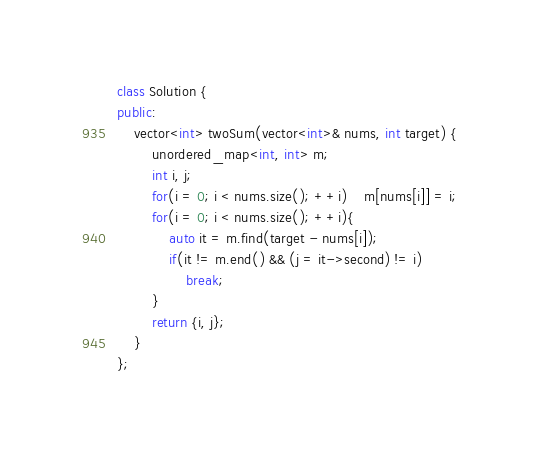<code> <loc_0><loc_0><loc_500><loc_500><_C++_>class Solution {
public:
    vector<int> twoSum(vector<int>& nums, int target) {
        unordered_map<int, int> m;
        int i, j;
        for(i = 0; i < nums.size(); ++i)    m[nums[i]] = i;
        for(i = 0; i < nums.size(); ++i){
            auto it = m.find(target - nums[i]);
            if(it != m.end() && (j = it->second) != i)
                break;
        }
        return {i, j};
    }
};</code> 